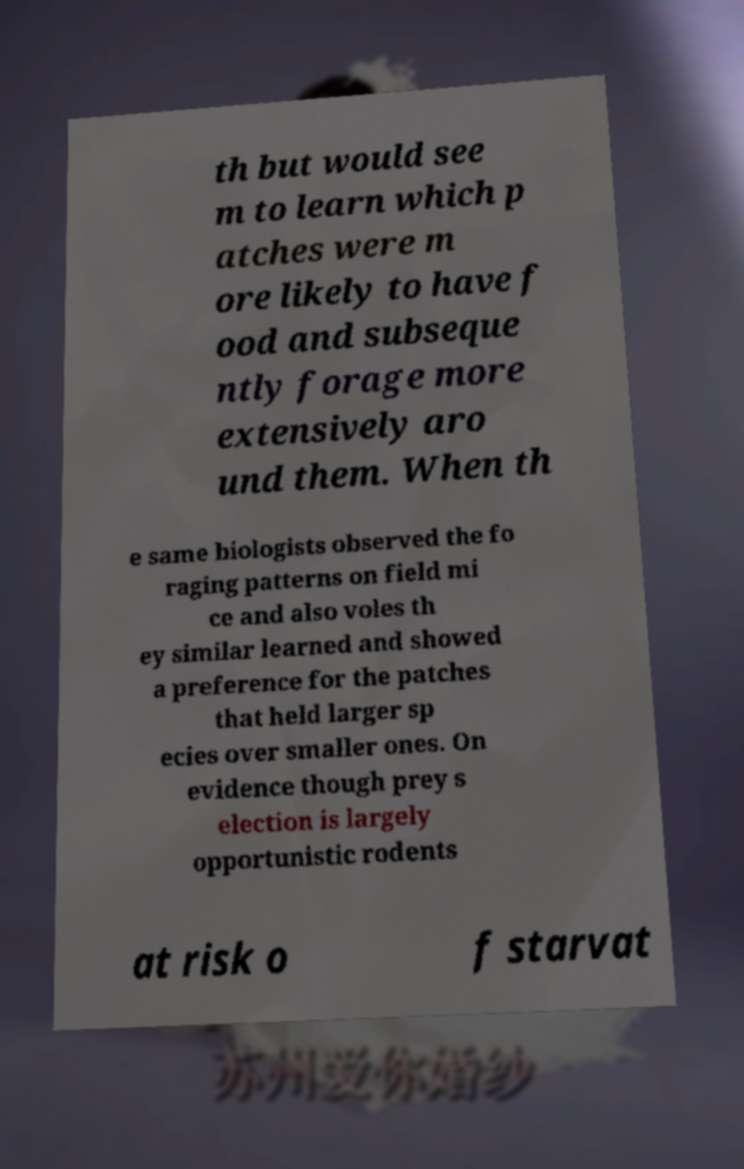There's text embedded in this image that I need extracted. Can you transcribe it verbatim? th but would see m to learn which p atches were m ore likely to have f ood and subseque ntly forage more extensively aro und them. When th e same biologists observed the fo raging patterns on field mi ce and also voles th ey similar learned and showed a preference for the patches that held larger sp ecies over smaller ones. On evidence though prey s election is largely opportunistic rodents at risk o f starvat 